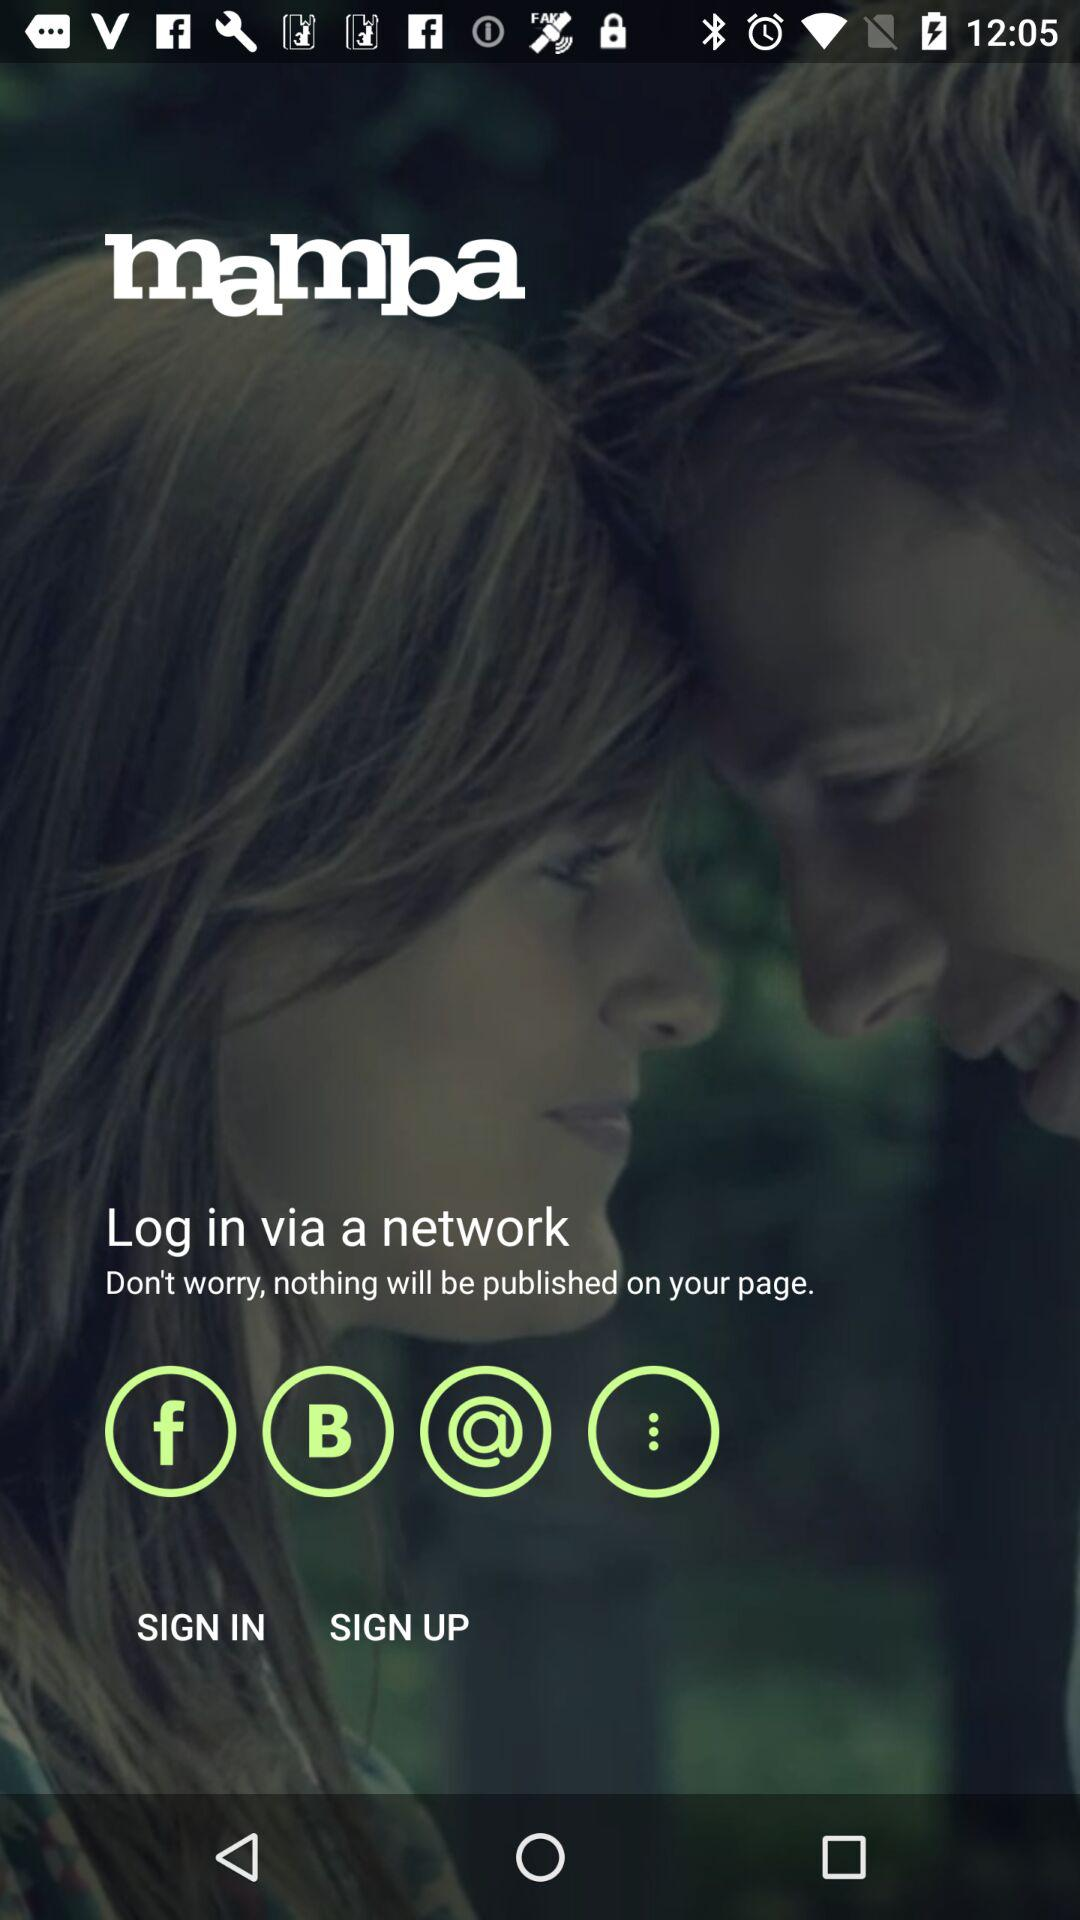What is the name of the application? The name of the application is "mamba". 